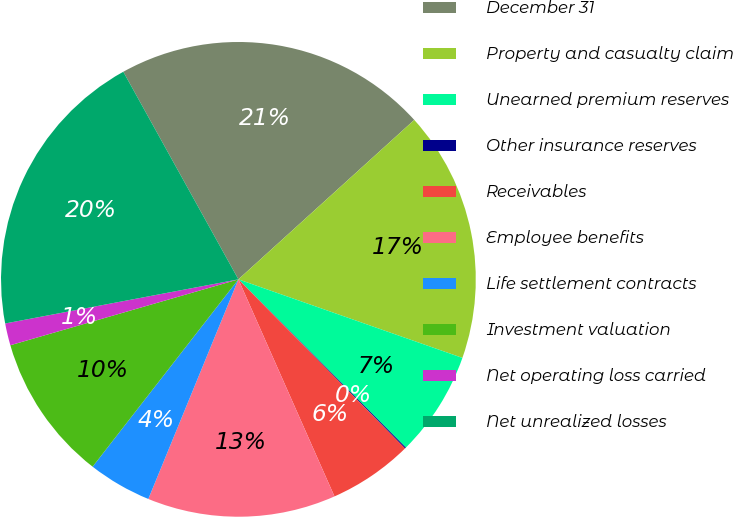<chart> <loc_0><loc_0><loc_500><loc_500><pie_chart><fcel>December 31<fcel>Property and casualty claim<fcel>Unearned premium reserves<fcel>Other insurance reserves<fcel>Receivables<fcel>Employee benefits<fcel>Life settlement contracts<fcel>Investment valuation<fcel>Net operating loss carried<fcel>Net unrealized losses<nl><fcel>21.34%<fcel>17.09%<fcel>7.17%<fcel>0.08%<fcel>5.75%<fcel>12.83%<fcel>4.33%<fcel>10.0%<fcel>1.5%<fcel>19.92%<nl></chart> 